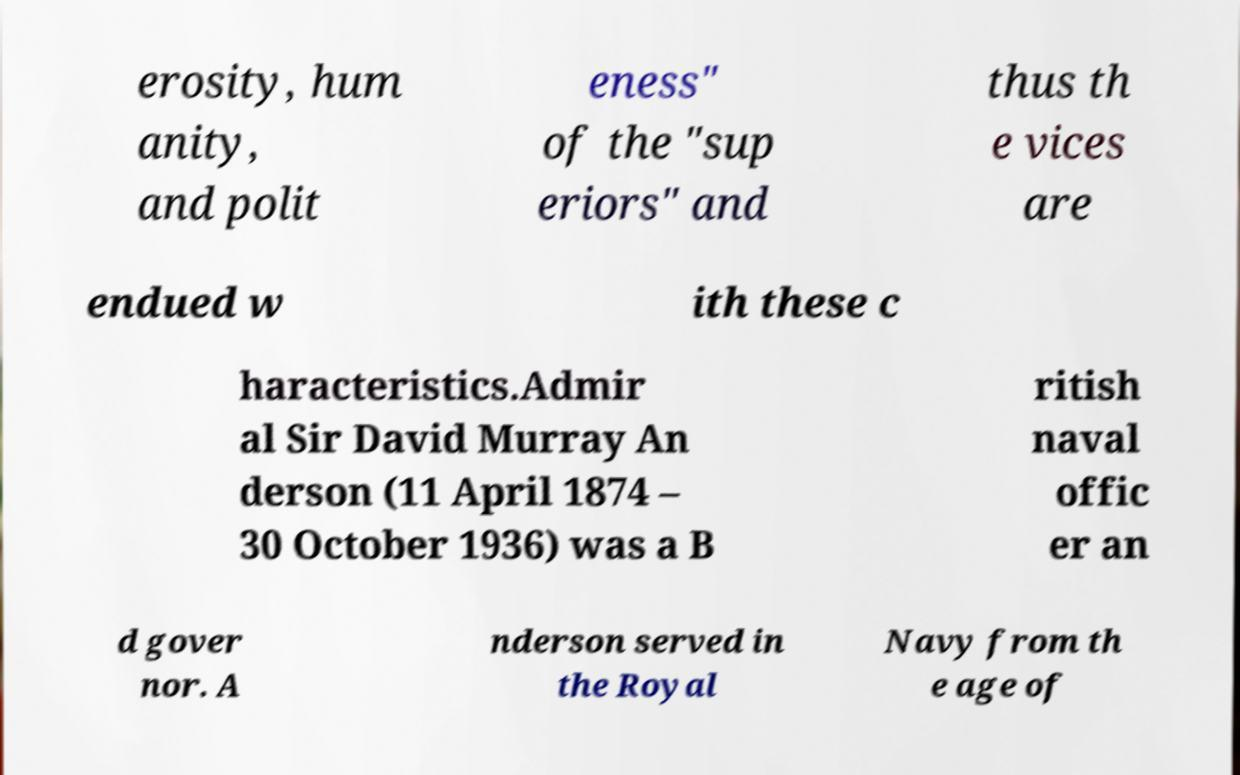What messages or text are displayed in this image? I need them in a readable, typed format. erosity, hum anity, and polit eness" of the "sup eriors" and thus th e vices are endued w ith these c haracteristics.Admir al Sir David Murray An derson (11 April 1874 – 30 October 1936) was a B ritish naval offic er an d gover nor. A nderson served in the Royal Navy from th e age of 